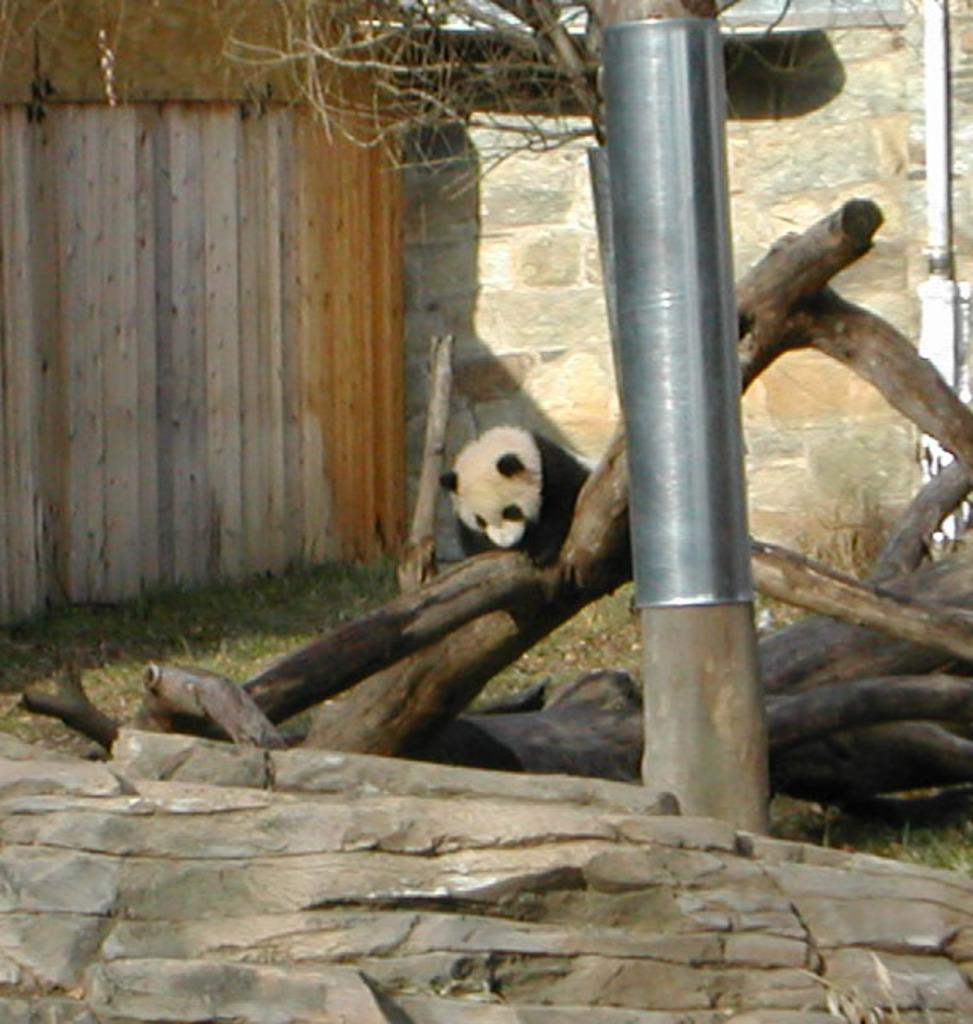What type of animal is in the image? There is a panda in the image. What natural elements can be seen in the image? There are wooden logs, grass, and stones visible in the image. What is attached to the tree in the image? There is a metal object attached to the tree in the image. What architectural feature is visible in the background of the image? There are walls visible in the background of the image. Where is the sofa located in the image? There is no sofa present in the image. How many ducks are visible in the image? There are no ducks present in the image. 